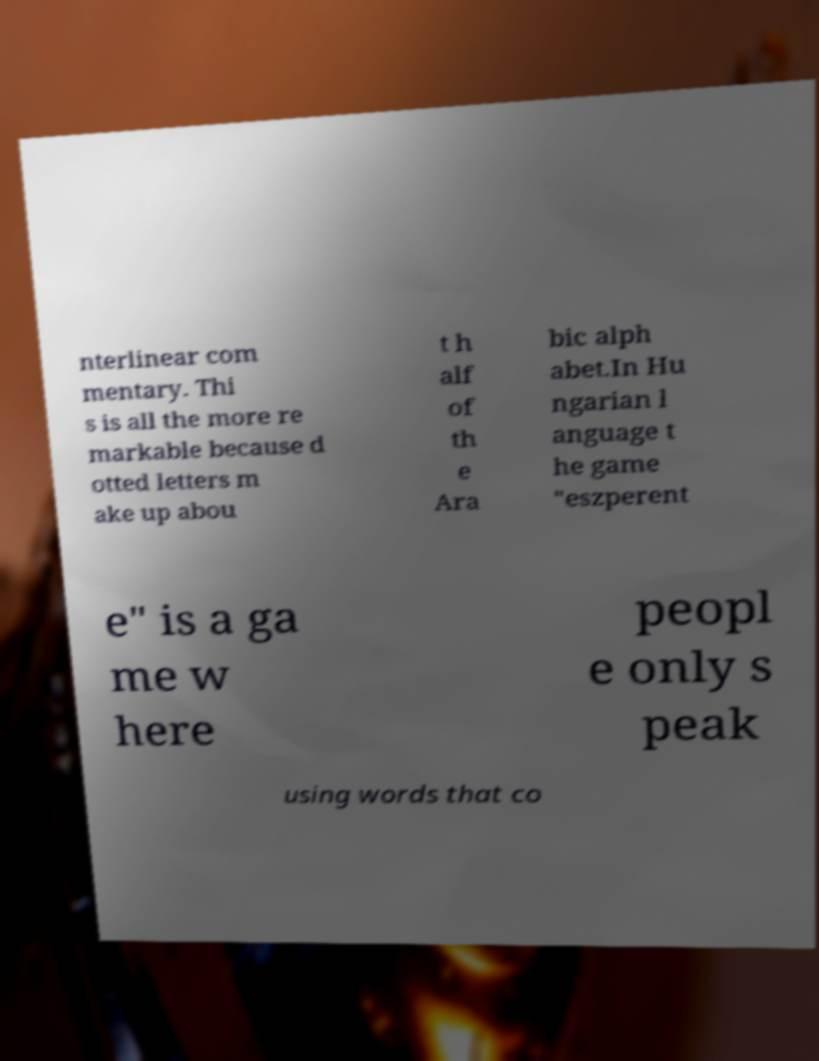What messages or text are displayed in this image? I need them in a readable, typed format. nterlinear com mentary. Thi s is all the more re markable because d otted letters m ake up abou t h alf of th e Ara bic alph abet.In Hu ngarian l anguage t he game "eszperent e" is a ga me w here peopl e only s peak using words that co 